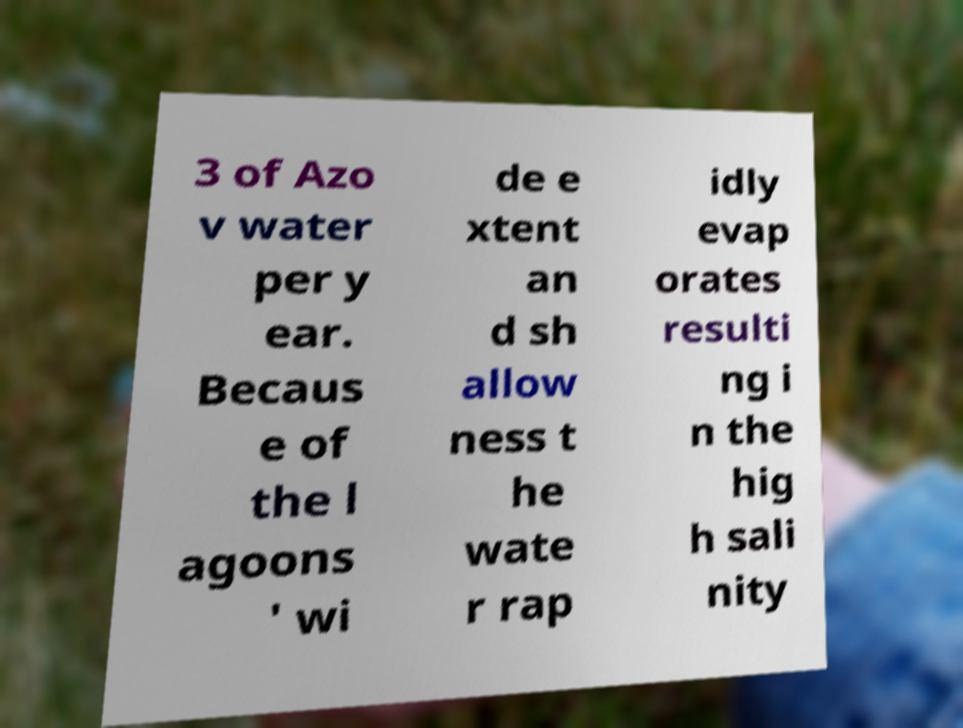Can you read and provide the text displayed in the image?This photo seems to have some interesting text. Can you extract and type it out for me? 3 of Azo v water per y ear. Becaus e of the l agoons ' wi de e xtent an d sh allow ness t he wate r rap idly evap orates resulti ng i n the hig h sali nity 